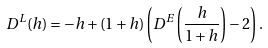Convert formula to latex. <formula><loc_0><loc_0><loc_500><loc_500>D ^ { L } ( h ) = - h + ( 1 + h ) \left ( D ^ { E } \left ( \frac { h } { 1 + h } \right ) - 2 \right ) .</formula> 